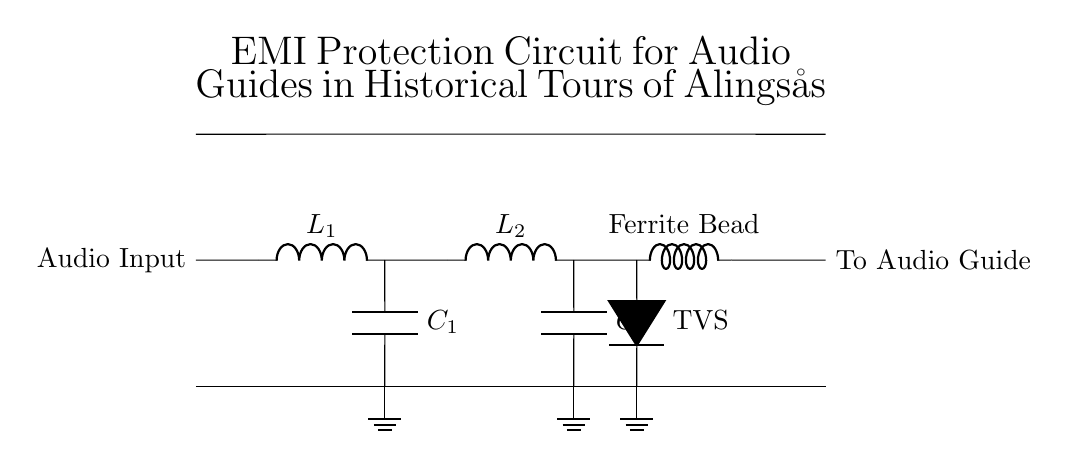What does L1 represent in this circuit? L1 is a component that indicates an inductor, used to block high-frequency noise while allowing lower frequencies to pass.
Answer: Inductor How many capacitors are in the circuit? The circuit contains two capacitors, C1 and C2, which are used for filtering out noise and stabilizing the voltage.
Answer: Two What is the function of the TVS diode? The TVS diode protects the circuit from voltage spikes and transients by clamping excessive voltage to a safe level.
Answer: Voltage protection What is the purpose of using a Ferrite Bead? The Ferrite Bead is used to suppress high-frequency noise in the circuit. It acts as a low-pass filter, allowing lower frequencies to pass through while attenuating higher frequencies.
Answer: Noise suppression How many inductors are in this circuit? The circuit has two inductors, L1 and L2, that help in controlling EMI by blocking high-frequency signals.
Answer: Two What is the total number of components listed in the circuit? The total number of components includes two inductors, two capacitors, one TVS diode, and one Ferrite Bead, making a total of six components.
Answer: Six 